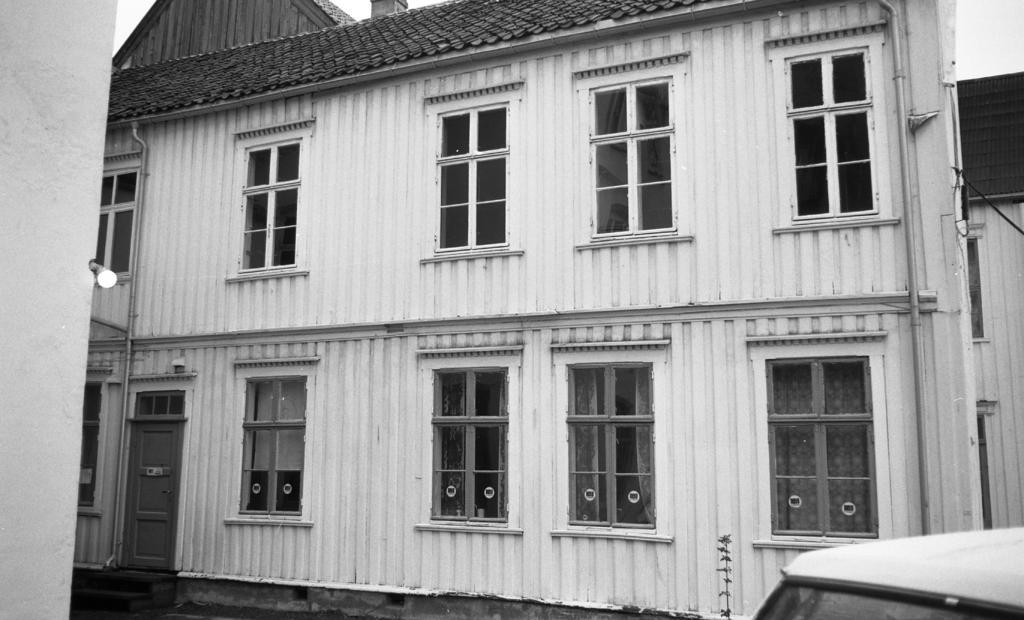Could you give a brief overview of what you see in this image? This is a black and white image where we can see a vehicle, here we can see a house with glass windows and a door and we can see the light and we can see the sky in the background. 